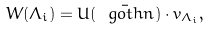<formula> <loc_0><loc_0><loc_500><loc_500>W ( \Lambda _ { i } ) = U ( \bar { \ g o t h { n } } ) \cdot v _ { \Lambda _ { i } } ,</formula> 